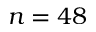<formula> <loc_0><loc_0><loc_500><loc_500>n = 4 8</formula> 